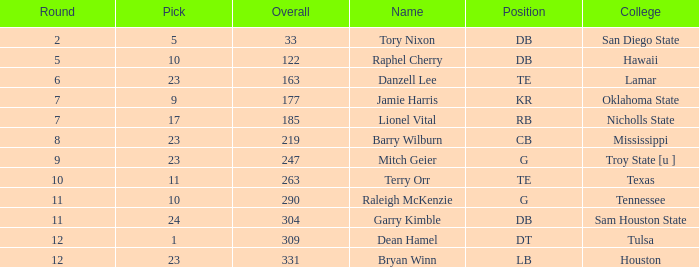Which Round is the highest one that has a Pick smaller than 10, and a Name of tory nixon? 2.0. 